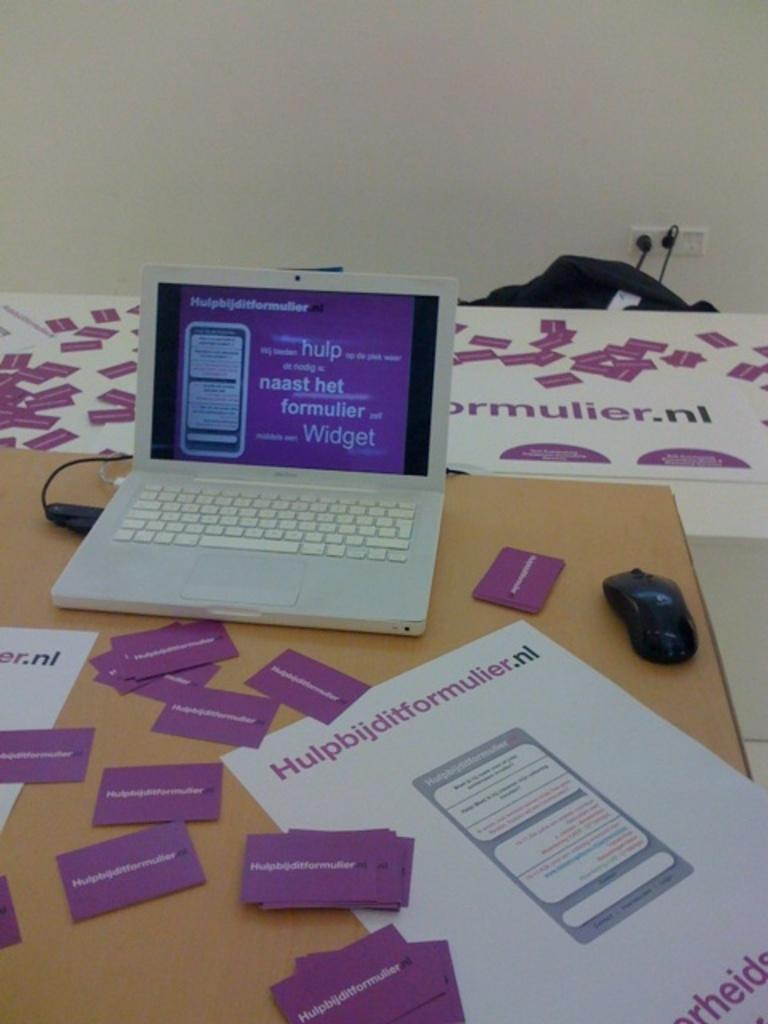<image>
Give a short and clear explanation of the subsequent image. A computer screen has a cluster of words on it, including hulp and Widget. 